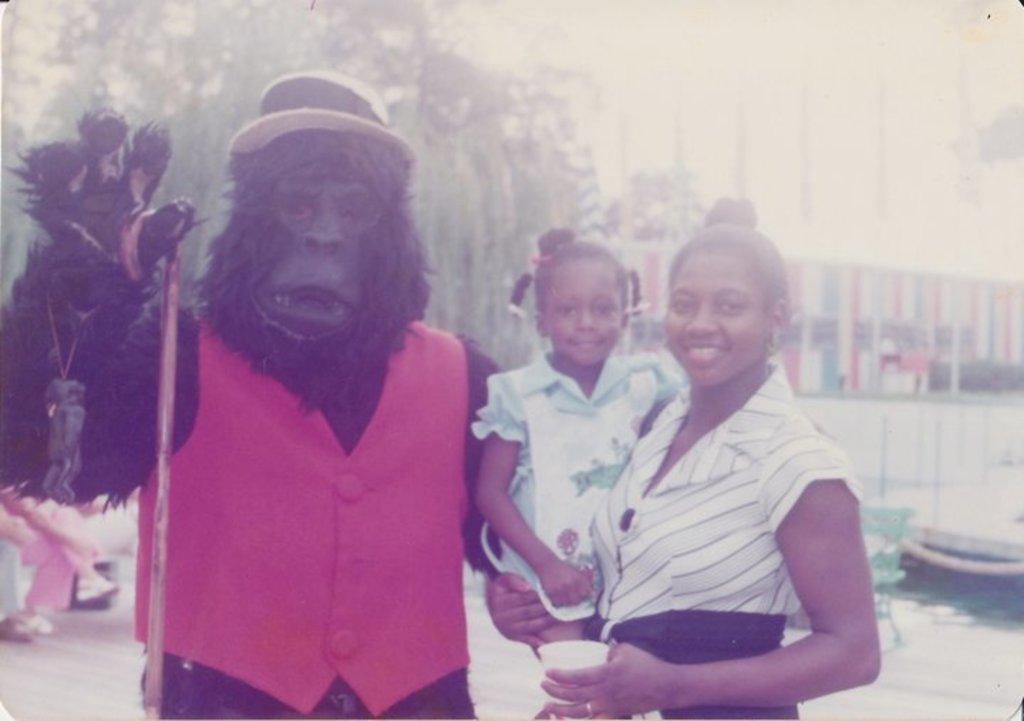Describe this image in one or two sentences. On the left side, we see a person wearing the chimpanzee costume is standing. Beside the person, we see a woman is standing. She is carrying the girl and she is smiling. She is holding a cup in her hand. They might be posing for the photo. Behind them, we see water and ships. In the left bottom, we see the legs of the person who is sitting on the bench. In the background, we see the trees and the buildings. This picture might be a photo frame. 